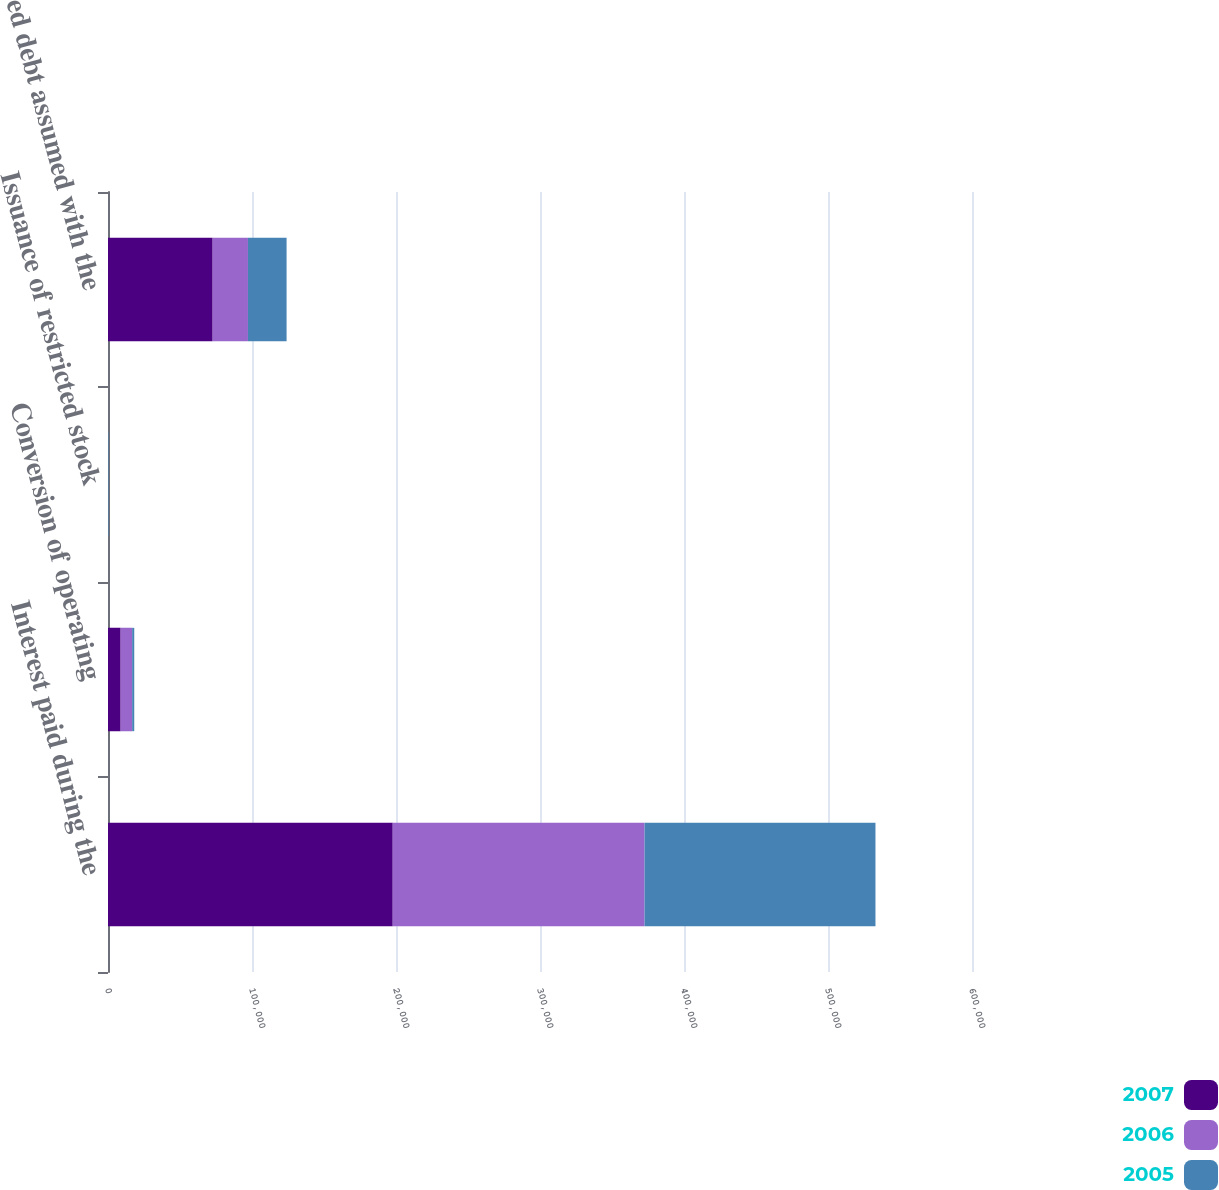Convert chart to OTSL. <chart><loc_0><loc_0><loc_500><loc_500><stacked_bar_chart><ecel><fcel>Interest paid during the<fcel>Conversion of operating<fcel>Issuance of restricted stock<fcel>Secured debt assumed with the<nl><fcel>2007<fcel>197722<fcel>8790<fcel>1<fcel>72680<nl><fcel>2006<fcel>174871<fcel>7988<fcel>3<fcel>24512<nl><fcel>2005<fcel>160367<fcel>1444<fcel>350<fcel>26825<nl></chart> 